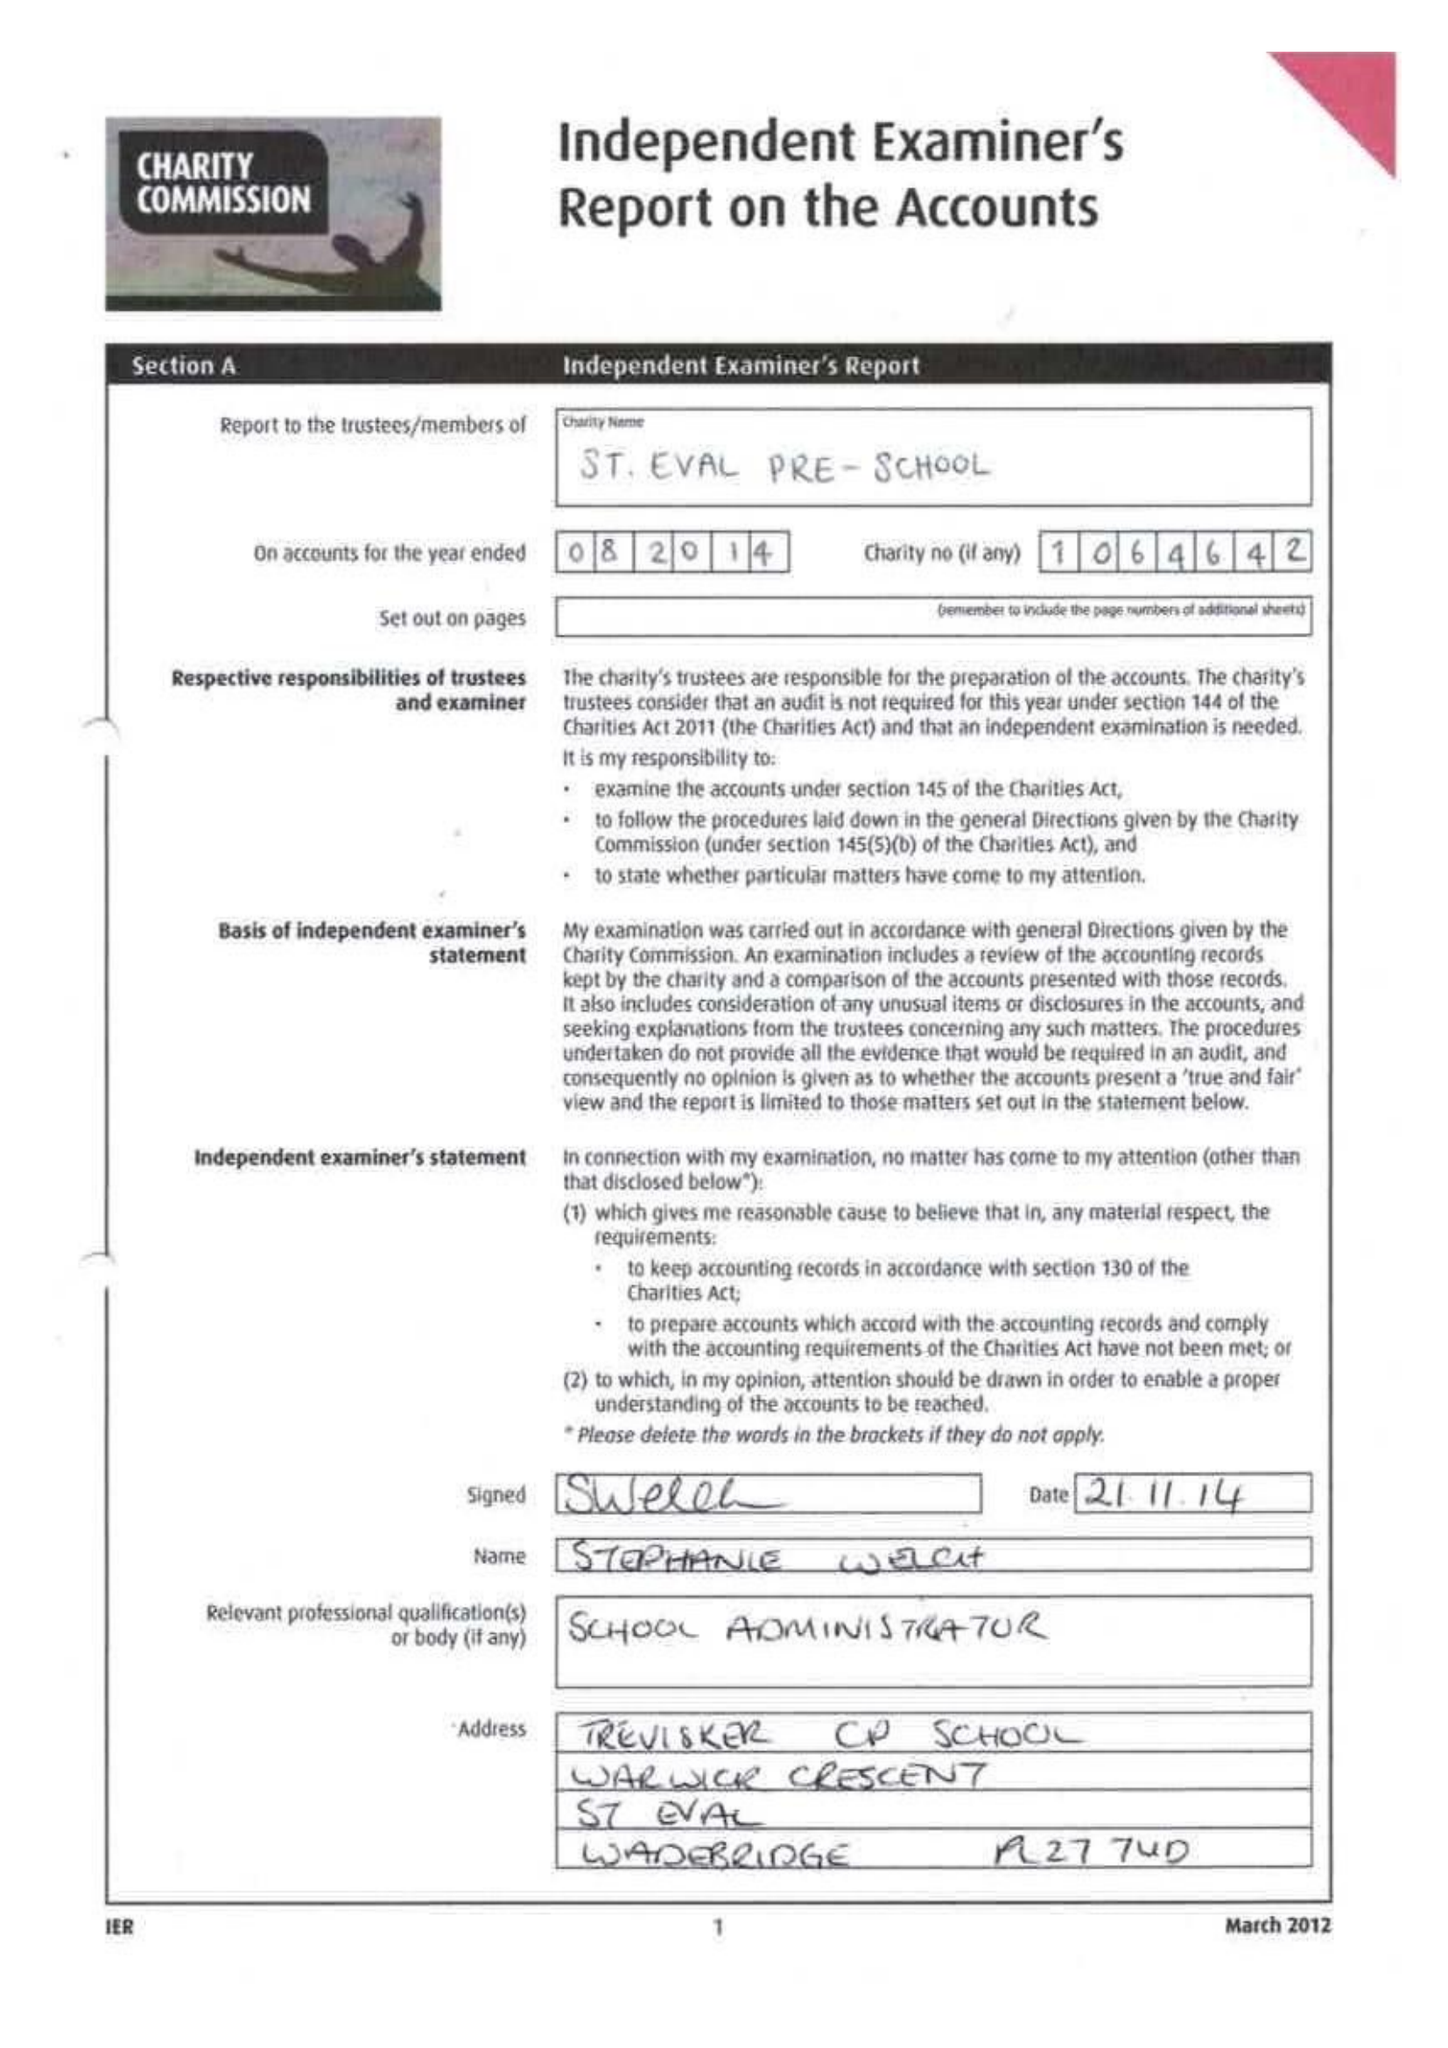What is the value for the report_date?
Answer the question using a single word or phrase. 2014-08-31 